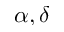Convert formula to latex. <formula><loc_0><loc_0><loc_500><loc_500>\alpha , \delta</formula> 